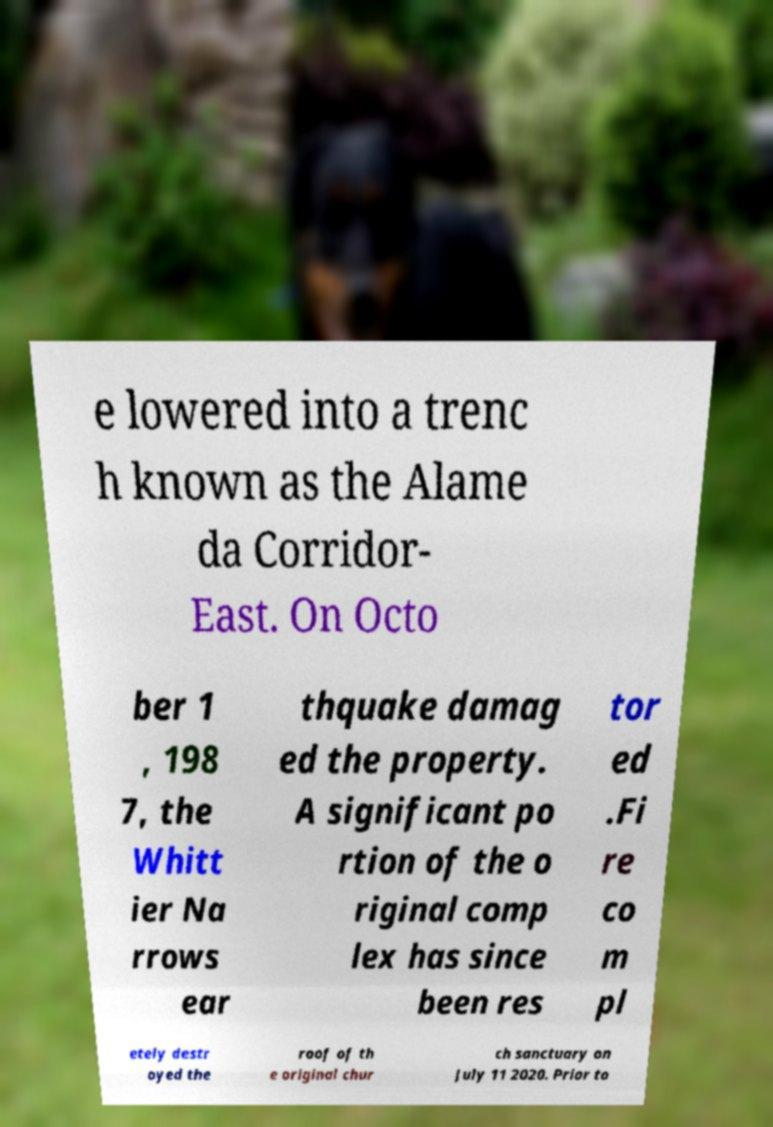Could you extract and type out the text from this image? e lowered into a trenc h known as the Alame da Corridor- East. On Octo ber 1 , 198 7, the Whitt ier Na rrows ear thquake damag ed the property. A significant po rtion of the o riginal comp lex has since been res tor ed .Fi re co m pl etely destr oyed the roof of th e original chur ch sanctuary on July 11 2020. Prior to 